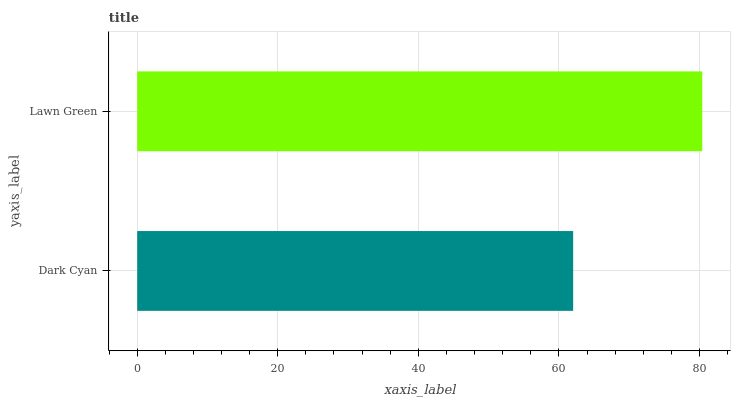Is Dark Cyan the minimum?
Answer yes or no. Yes. Is Lawn Green the maximum?
Answer yes or no. Yes. Is Lawn Green the minimum?
Answer yes or no. No. Is Lawn Green greater than Dark Cyan?
Answer yes or no. Yes. Is Dark Cyan less than Lawn Green?
Answer yes or no. Yes. Is Dark Cyan greater than Lawn Green?
Answer yes or no. No. Is Lawn Green less than Dark Cyan?
Answer yes or no. No. Is Lawn Green the high median?
Answer yes or no. Yes. Is Dark Cyan the low median?
Answer yes or no. Yes. Is Dark Cyan the high median?
Answer yes or no. No. Is Lawn Green the low median?
Answer yes or no. No. 